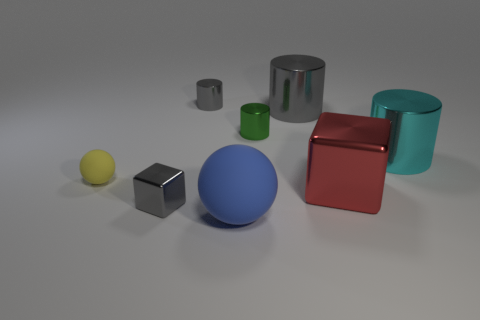Is the small block made of the same material as the big thing that is behind the cyan cylinder?
Provide a succinct answer. Yes. The tiny thing right of the small gray thing behind the rubber ball behind the red metal cube is what color?
Provide a succinct answer. Green. Is there anything else that is the same shape as the green object?
Your answer should be compact. Yes. Is the number of small objects greater than the number of tiny matte balls?
Your answer should be very brief. Yes. How many objects are on the right side of the big rubber object and left of the gray shiny cube?
Give a very brief answer. 0. How many large gray metallic cylinders are on the right side of the big shiny cylinder on the left side of the cyan metallic cylinder?
Offer a terse response. 0. There is a rubber object in front of the yellow thing; does it have the same size as the cube to the left of the large gray metal cylinder?
Ensure brevity in your answer.  No. How many tiny matte balls are there?
Offer a terse response. 1. How many large cylinders have the same material as the green object?
Your response must be concise. 2. Are there the same number of tiny yellow rubber objects that are in front of the large blue matte thing and large cyan shiny objects?
Keep it short and to the point. No. 